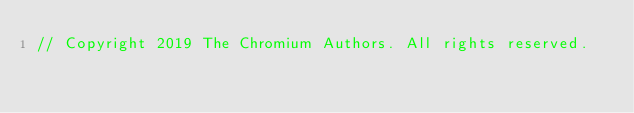<code> <loc_0><loc_0><loc_500><loc_500><_ObjectiveC_>// Copyright 2019 The Chromium Authors. All rights reserved.</code> 